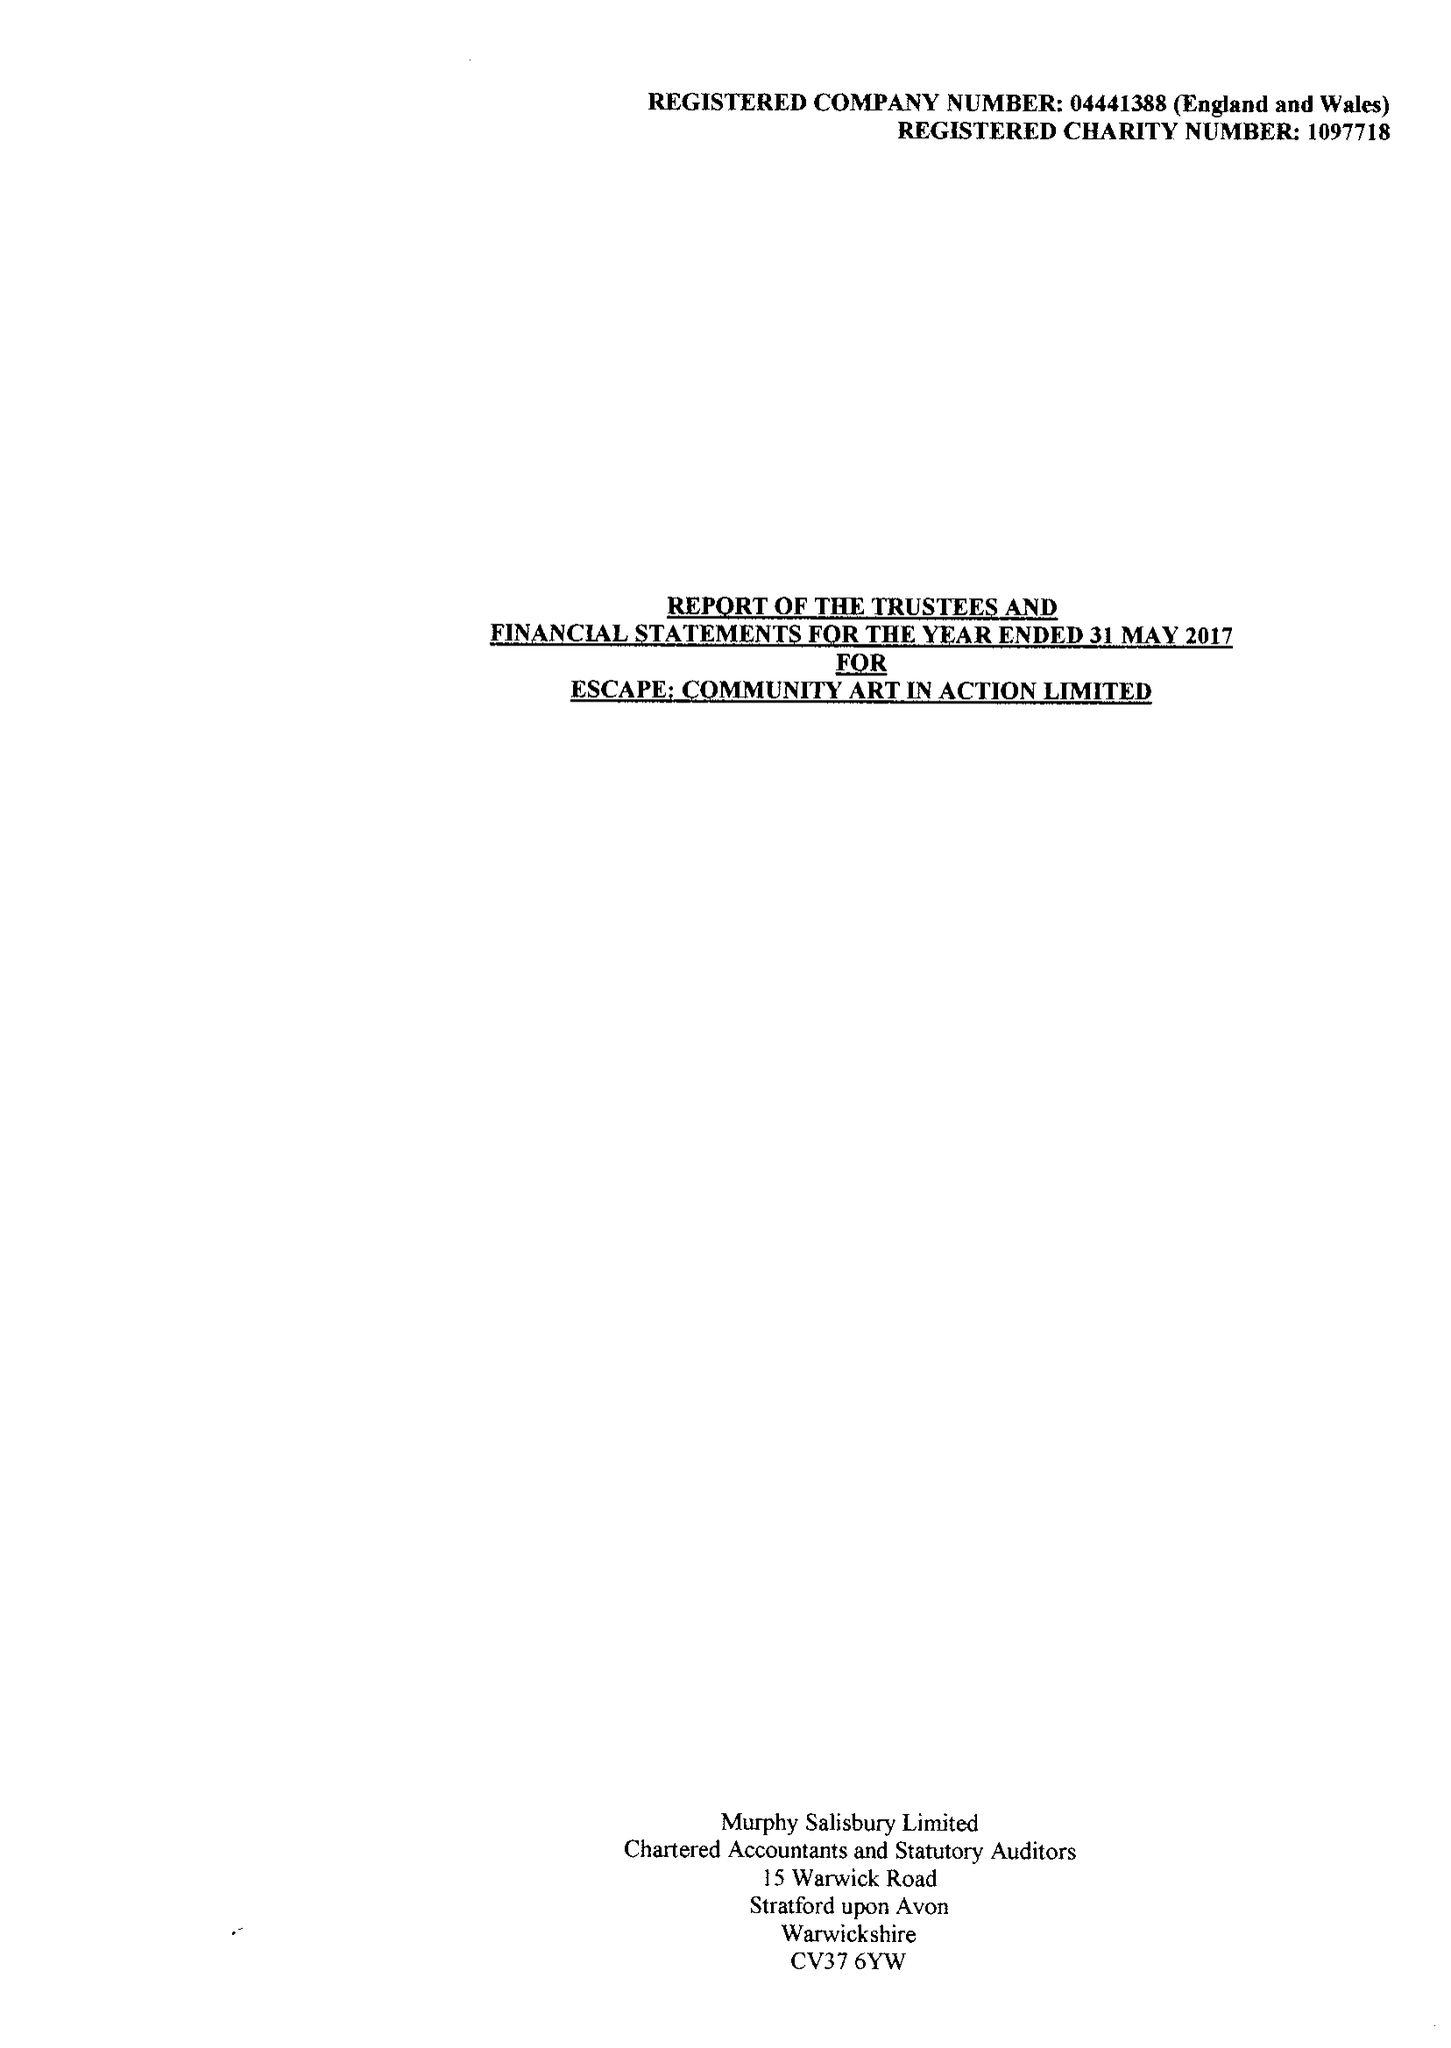What is the value for the address__street_line?
Answer the question using a single word or phrase. SHEEP STREET 